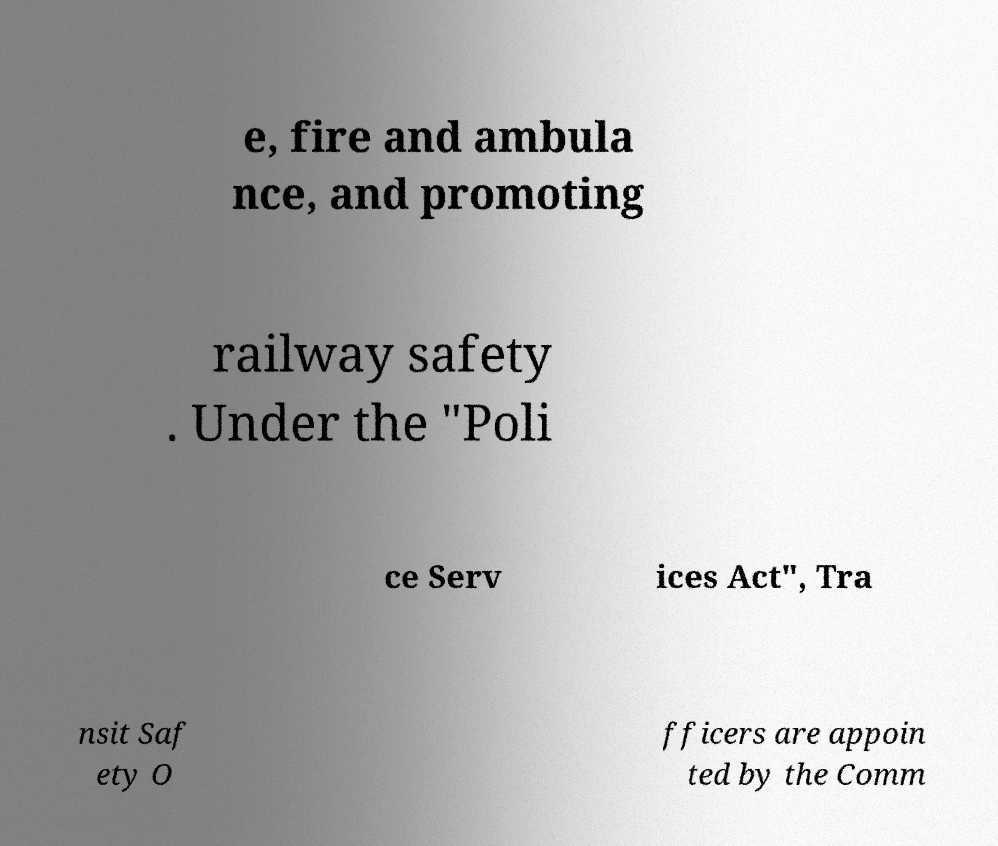For documentation purposes, I need the text within this image transcribed. Could you provide that? e, fire and ambula nce, and promoting railway safety . Under the "Poli ce Serv ices Act", Tra nsit Saf ety O fficers are appoin ted by the Comm 